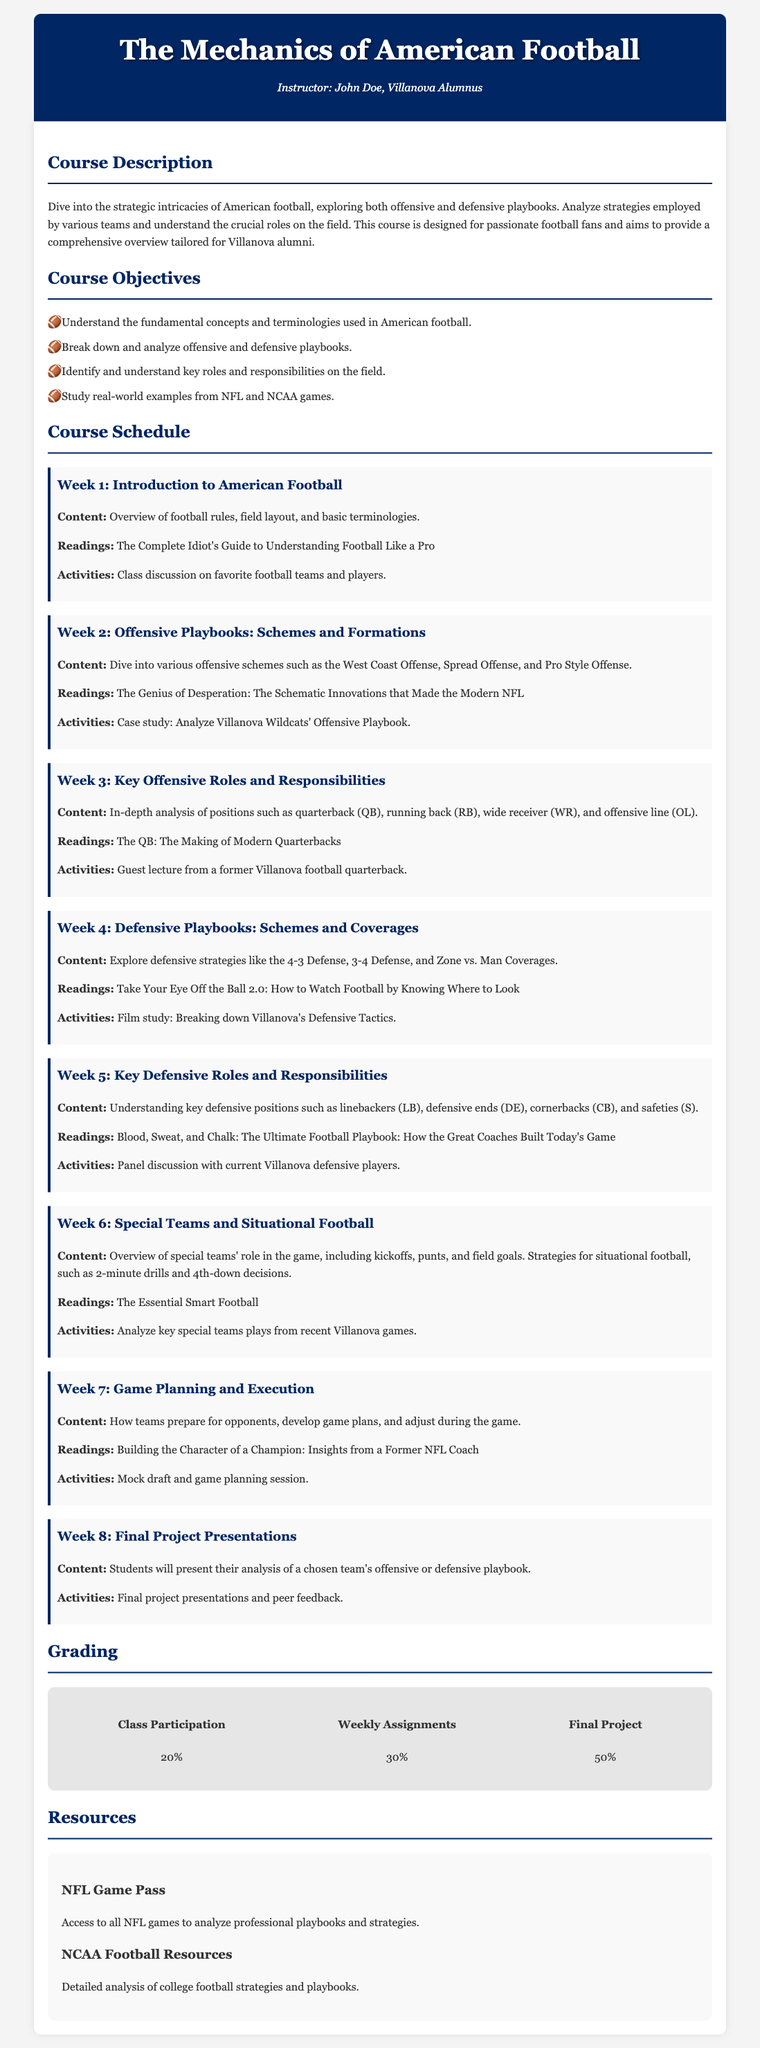What is the title of the course? The title of the course is mentioned in the header of the document.
Answer: The Mechanics of American Football Who is the instructor? The instructor's name is provided in the header section of the syllabus.
Answer: John Doe What percentage of the grade is based on the final project? The grading section specifies the percentage breakdown of the final project within the overall grading scheme.
Answer: 50% What is the content of Week 3? The syllabus outlines the weekly topics, and Week 3 content details the focus on key offensive roles.
Answer: In-depth analysis of positions such as quarterback, running back, wide receiver, and offensive line Which reading is associated with Week 4? The readings for each week are listed, and for Week 4, this specific reading is mentioned.
Answer: Take Your Eye Off the Ball 2.0: How to Watch Football by Knowing Where to Look What is the focus of Week 6's content? The syllabus provides a brief overview of each week's content, which for Week 6 specifically addresses special teams.
Answer: Overview of special teams' role in the game, including kickoffs, punts, and field goals What activity is planned for Week 2? The syllabus includes activities for each week, and Week 2 has a specific activity outlined.
Answer: Case study: Analyze Villanova Wildcats' Offensive Playbook What is the total number of weeks in the course schedule? Counting the individual weeks listed in the course schedule reveals the total number.
Answer: 8 